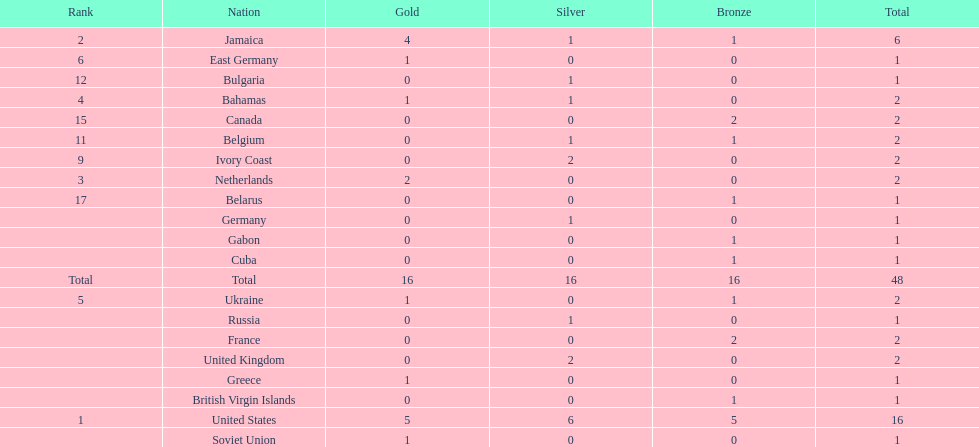What number of nations received 1 medal? 10. 